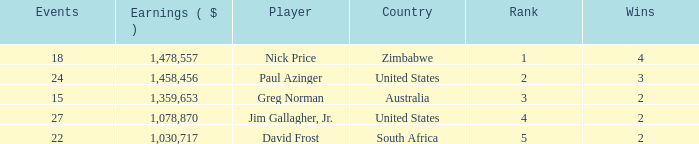How many events are in South Africa? 22.0. 